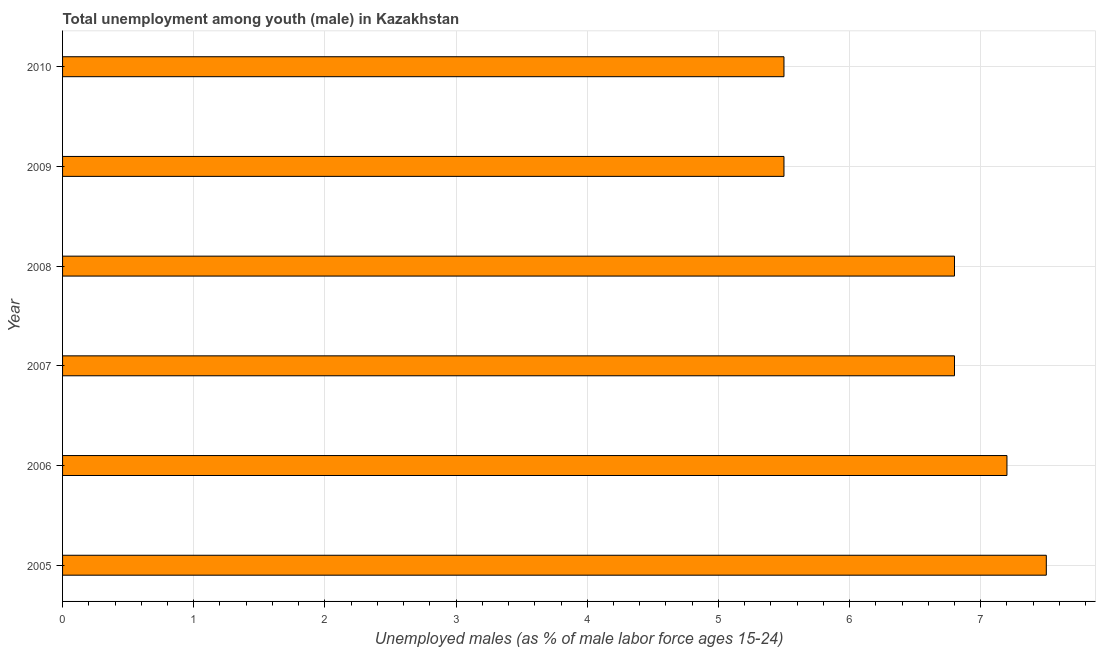Does the graph contain grids?
Your response must be concise. Yes. What is the title of the graph?
Provide a short and direct response. Total unemployment among youth (male) in Kazakhstan. What is the label or title of the X-axis?
Your response must be concise. Unemployed males (as % of male labor force ages 15-24). What is the unemployed male youth population in 2006?
Ensure brevity in your answer.  7.2. Across all years, what is the minimum unemployed male youth population?
Your response must be concise. 5.5. In which year was the unemployed male youth population maximum?
Give a very brief answer. 2005. What is the sum of the unemployed male youth population?
Offer a terse response. 39.3. What is the average unemployed male youth population per year?
Provide a succinct answer. 6.55. What is the median unemployed male youth population?
Make the answer very short. 6.8. What is the ratio of the unemployed male youth population in 2005 to that in 2009?
Make the answer very short. 1.36. Is the unemployed male youth population in 2007 less than that in 2010?
Offer a terse response. No. What is the difference between the highest and the second highest unemployed male youth population?
Offer a terse response. 0.3. What is the difference between the highest and the lowest unemployed male youth population?
Ensure brevity in your answer.  2. Are all the bars in the graph horizontal?
Provide a short and direct response. Yes. What is the difference between two consecutive major ticks on the X-axis?
Offer a terse response. 1. Are the values on the major ticks of X-axis written in scientific E-notation?
Offer a terse response. No. What is the Unemployed males (as % of male labor force ages 15-24) of 2005?
Make the answer very short. 7.5. What is the Unemployed males (as % of male labor force ages 15-24) of 2006?
Your answer should be very brief. 7.2. What is the Unemployed males (as % of male labor force ages 15-24) in 2007?
Offer a terse response. 6.8. What is the Unemployed males (as % of male labor force ages 15-24) in 2008?
Make the answer very short. 6.8. What is the difference between the Unemployed males (as % of male labor force ages 15-24) in 2005 and 2006?
Provide a succinct answer. 0.3. What is the difference between the Unemployed males (as % of male labor force ages 15-24) in 2005 and 2008?
Ensure brevity in your answer.  0.7. What is the difference between the Unemployed males (as % of male labor force ages 15-24) in 2006 and 2007?
Offer a terse response. 0.4. What is the difference between the Unemployed males (as % of male labor force ages 15-24) in 2007 and 2009?
Provide a succinct answer. 1.3. What is the difference between the Unemployed males (as % of male labor force ages 15-24) in 2007 and 2010?
Provide a short and direct response. 1.3. What is the difference between the Unemployed males (as % of male labor force ages 15-24) in 2008 and 2010?
Your response must be concise. 1.3. What is the difference between the Unemployed males (as % of male labor force ages 15-24) in 2009 and 2010?
Offer a terse response. 0. What is the ratio of the Unemployed males (as % of male labor force ages 15-24) in 2005 to that in 2006?
Provide a succinct answer. 1.04. What is the ratio of the Unemployed males (as % of male labor force ages 15-24) in 2005 to that in 2007?
Offer a terse response. 1.1. What is the ratio of the Unemployed males (as % of male labor force ages 15-24) in 2005 to that in 2008?
Keep it short and to the point. 1.1. What is the ratio of the Unemployed males (as % of male labor force ages 15-24) in 2005 to that in 2009?
Ensure brevity in your answer.  1.36. What is the ratio of the Unemployed males (as % of male labor force ages 15-24) in 2005 to that in 2010?
Offer a very short reply. 1.36. What is the ratio of the Unemployed males (as % of male labor force ages 15-24) in 2006 to that in 2007?
Provide a short and direct response. 1.06. What is the ratio of the Unemployed males (as % of male labor force ages 15-24) in 2006 to that in 2008?
Your answer should be compact. 1.06. What is the ratio of the Unemployed males (as % of male labor force ages 15-24) in 2006 to that in 2009?
Ensure brevity in your answer.  1.31. What is the ratio of the Unemployed males (as % of male labor force ages 15-24) in 2006 to that in 2010?
Your answer should be very brief. 1.31. What is the ratio of the Unemployed males (as % of male labor force ages 15-24) in 2007 to that in 2009?
Provide a succinct answer. 1.24. What is the ratio of the Unemployed males (as % of male labor force ages 15-24) in 2007 to that in 2010?
Your answer should be compact. 1.24. What is the ratio of the Unemployed males (as % of male labor force ages 15-24) in 2008 to that in 2009?
Offer a terse response. 1.24. What is the ratio of the Unemployed males (as % of male labor force ages 15-24) in 2008 to that in 2010?
Provide a short and direct response. 1.24. 